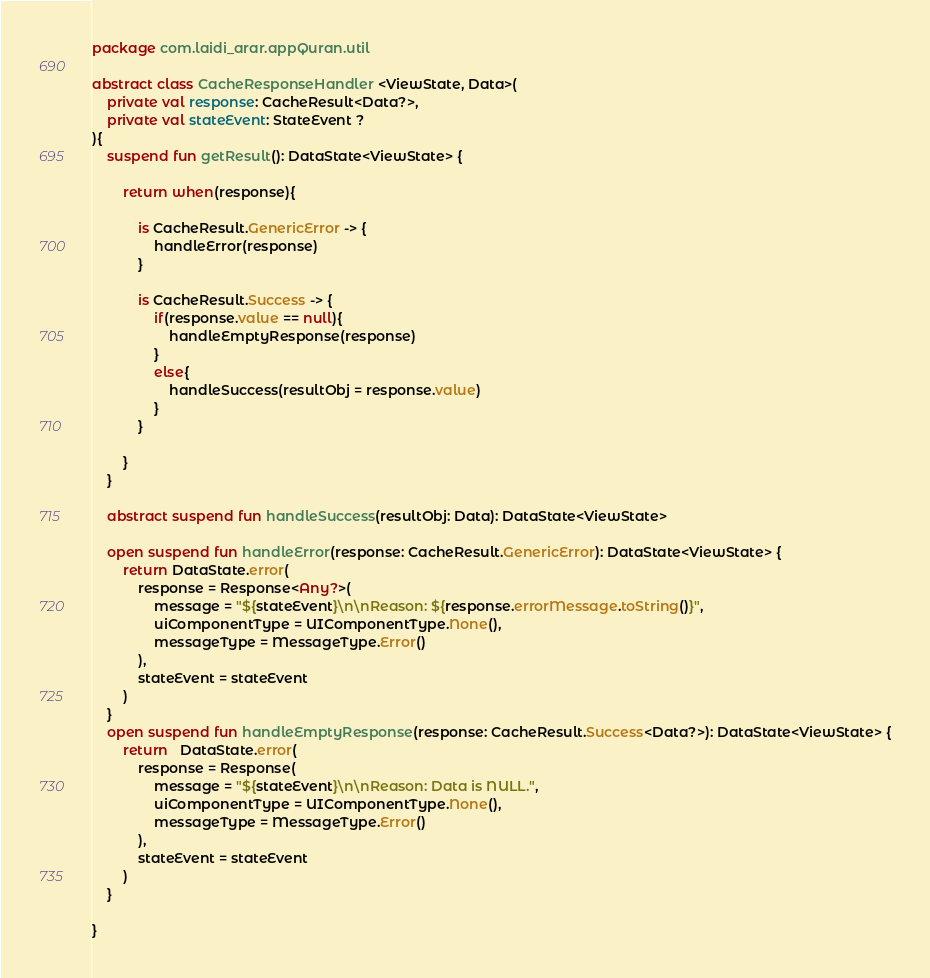<code> <loc_0><loc_0><loc_500><loc_500><_Kotlin_>package com.laidi_arar.appQuran.util

abstract class CacheResponseHandler <ViewState, Data>(
    private val response: CacheResult<Data?>,
    private val stateEvent: StateEvent ?
){
    suspend fun getResult(): DataState<ViewState> {

        return when(response){

            is CacheResult.GenericError -> {
                handleError(response)
            }

            is CacheResult.Success -> {
                if(response.value == null){
                    handleEmptyResponse(response)
                }
                else{
                    handleSuccess(resultObj = response.value)
                }
            }

        }
    }

    abstract suspend fun handleSuccess(resultObj: Data): DataState<ViewState>

    open suspend fun handleError(response: CacheResult.GenericError): DataState<ViewState> {
        return DataState.error(
            response = Response<Any?>(
                message = "${stateEvent}\n\nReason: ${response.errorMessage.toString()}",
                uiComponentType = UIComponentType.None(),
                messageType = MessageType.Error()
            ),
            stateEvent = stateEvent
        )
    }
    open suspend fun handleEmptyResponse(response: CacheResult.Success<Data?>): DataState<ViewState> {
        return   DataState.error(
            response = Response(
                message = "${stateEvent}\n\nReason: Data is NULL.",
                uiComponentType = UIComponentType.None(),
                messageType = MessageType.Error()
            ),
            stateEvent = stateEvent
        )
    }

}</code> 